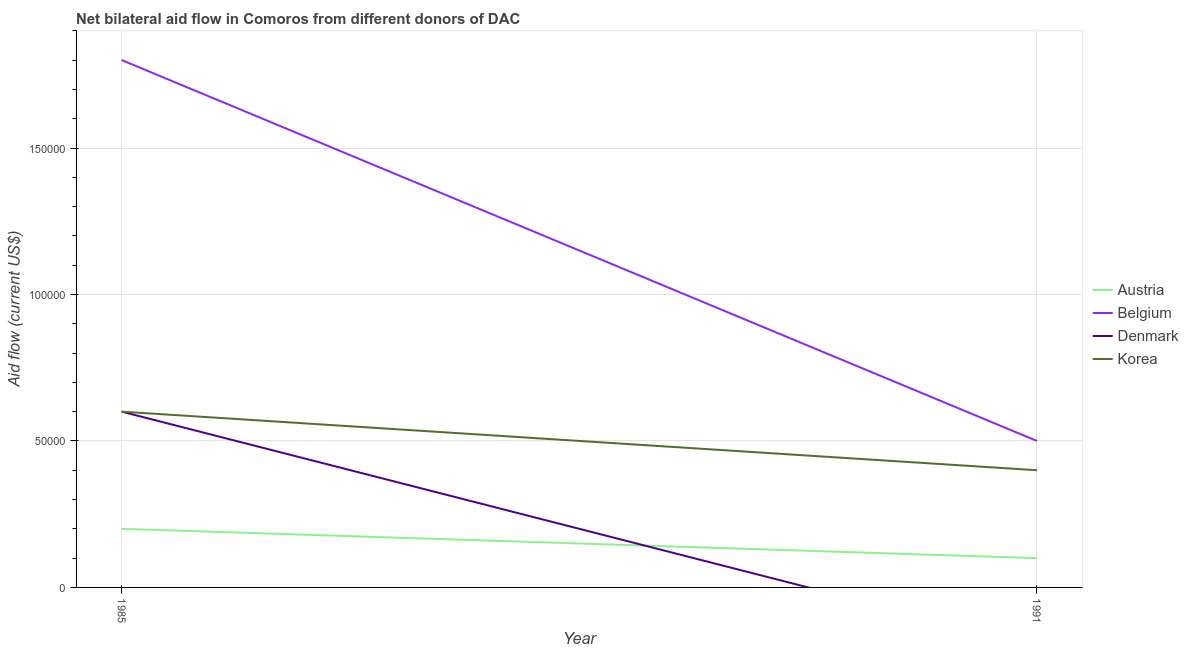Does the line corresponding to amount of aid given by austria intersect with the line corresponding to amount of aid given by korea?
Make the answer very short. No. Is the number of lines equal to the number of legend labels?
Your answer should be very brief. No. What is the amount of aid given by korea in 1991?
Provide a succinct answer. 4.00e+04. Across all years, what is the maximum amount of aid given by denmark?
Your answer should be compact. 6.00e+04. Across all years, what is the minimum amount of aid given by korea?
Offer a terse response. 4.00e+04. What is the total amount of aid given by korea in the graph?
Give a very brief answer. 1.00e+05. What is the difference between the amount of aid given by korea in 1985 and that in 1991?
Ensure brevity in your answer.  2.00e+04. What is the difference between the amount of aid given by austria in 1991 and the amount of aid given by belgium in 1985?
Give a very brief answer. -1.70e+05. What is the average amount of aid given by belgium per year?
Your response must be concise. 1.15e+05. In the year 1991, what is the difference between the amount of aid given by belgium and amount of aid given by austria?
Offer a very short reply. 4.00e+04. In how many years, is the amount of aid given by belgium greater than 60000 US$?
Ensure brevity in your answer.  1. What is the ratio of the amount of aid given by belgium in 1985 to that in 1991?
Your response must be concise. 3.6. Is the amount of aid given by belgium in 1985 less than that in 1991?
Your answer should be very brief. No. In how many years, is the amount of aid given by austria greater than the average amount of aid given by austria taken over all years?
Your answer should be very brief. 1. Is it the case that in every year, the sum of the amount of aid given by korea and amount of aid given by belgium is greater than the sum of amount of aid given by austria and amount of aid given by denmark?
Keep it short and to the point. No. Does the amount of aid given by korea monotonically increase over the years?
Offer a terse response. No. Does the graph contain any zero values?
Your response must be concise. Yes. Where does the legend appear in the graph?
Keep it short and to the point. Center right. How many legend labels are there?
Give a very brief answer. 4. How are the legend labels stacked?
Your answer should be very brief. Vertical. What is the title of the graph?
Offer a terse response. Net bilateral aid flow in Comoros from different donors of DAC. What is the label or title of the X-axis?
Keep it short and to the point. Year. What is the Aid flow (current US$) in Austria in 1985?
Ensure brevity in your answer.  2.00e+04. What is the Aid flow (current US$) of Belgium in 1985?
Your answer should be compact. 1.80e+05. What is the Aid flow (current US$) in Denmark in 1985?
Your response must be concise. 6.00e+04. What is the Aid flow (current US$) in Denmark in 1991?
Your answer should be very brief. 0. What is the Aid flow (current US$) in Korea in 1991?
Your answer should be compact. 4.00e+04. Across all years, what is the maximum Aid flow (current US$) in Belgium?
Give a very brief answer. 1.80e+05. Across all years, what is the maximum Aid flow (current US$) in Denmark?
Your answer should be very brief. 6.00e+04. Across all years, what is the minimum Aid flow (current US$) in Austria?
Offer a very short reply. 10000. Across all years, what is the minimum Aid flow (current US$) in Belgium?
Give a very brief answer. 5.00e+04. Across all years, what is the minimum Aid flow (current US$) of Korea?
Provide a short and direct response. 4.00e+04. What is the total Aid flow (current US$) in Austria in the graph?
Give a very brief answer. 3.00e+04. What is the difference between the Aid flow (current US$) of Austria in 1985 and that in 1991?
Give a very brief answer. 10000. What is the difference between the Aid flow (current US$) in Korea in 1985 and that in 1991?
Offer a very short reply. 2.00e+04. What is the difference between the Aid flow (current US$) of Belgium in 1985 and the Aid flow (current US$) of Korea in 1991?
Offer a terse response. 1.40e+05. What is the average Aid flow (current US$) of Austria per year?
Make the answer very short. 1.50e+04. What is the average Aid flow (current US$) of Belgium per year?
Provide a succinct answer. 1.15e+05. In the year 1985, what is the difference between the Aid flow (current US$) in Belgium and Aid flow (current US$) in Denmark?
Make the answer very short. 1.20e+05. In the year 1985, what is the difference between the Aid flow (current US$) in Denmark and Aid flow (current US$) in Korea?
Make the answer very short. 0. In the year 1991, what is the difference between the Aid flow (current US$) in Austria and Aid flow (current US$) in Belgium?
Give a very brief answer. -4.00e+04. In the year 1991, what is the difference between the Aid flow (current US$) in Austria and Aid flow (current US$) in Korea?
Your answer should be compact. -3.00e+04. In the year 1991, what is the difference between the Aid flow (current US$) of Belgium and Aid flow (current US$) of Korea?
Provide a succinct answer. 10000. What is the ratio of the Aid flow (current US$) in Belgium in 1985 to that in 1991?
Give a very brief answer. 3.6. What is the difference between the highest and the second highest Aid flow (current US$) in Austria?
Your answer should be compact. 10000. What is the difference between the highest and the second highest Aid flow (current US$) in Belgium?
Offer a very short reply. 1.30e+05. What is the difference between the highest and the second highest Aid flow (current US$) in Korea?
Your answer should be very brief. 2.00e+04. What is the difference between the highest and the lowest Aid flow (current US$) of Belgium?
Give a very brief answer. 1.30e+05. What is the difference between the highest and the lowest Aid flow (current US$) of Denmark?
Keep it short and to the point. 6.00e+04. What is the difference between the highest and the lowest Aid flow (current US$) of Korea?
Your answer should be very brief. 2.00e+04. 